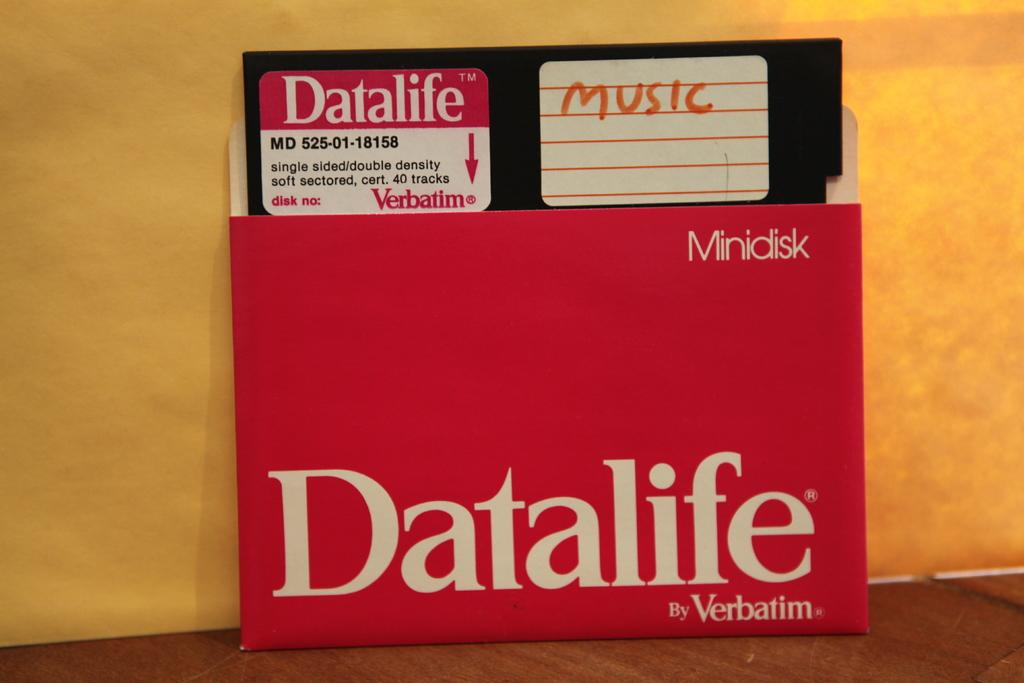<image>
Relay a brief, clear account of the picture shown. A minidisk from Datalife by Verbatim is labeled Music. 